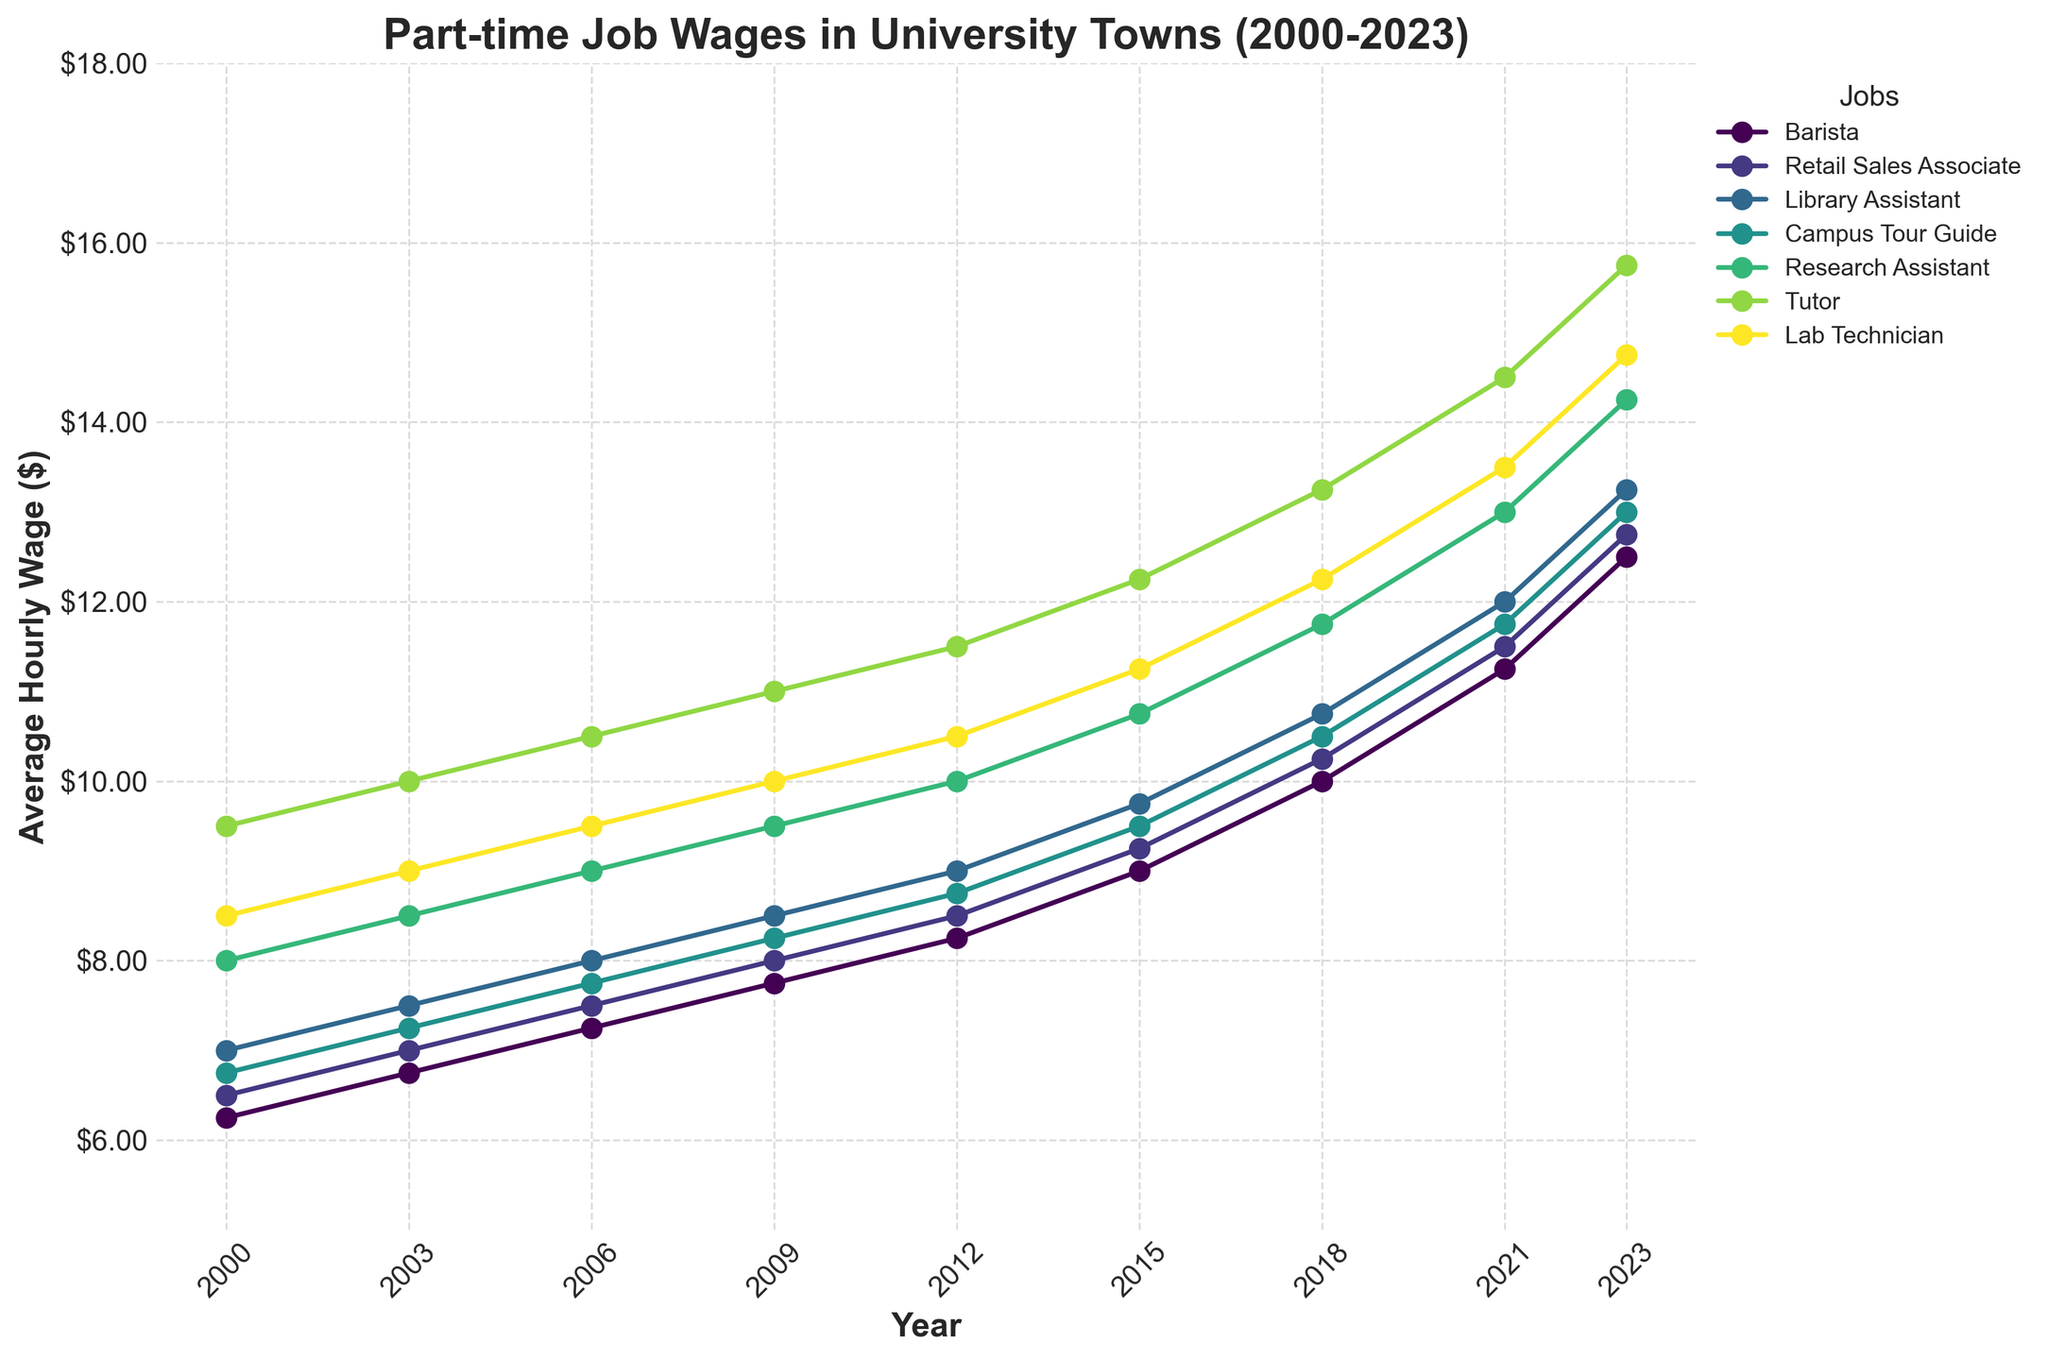What is the overall trend of the average hourly wage for Barista from 2000 to 2023? Look at the line representing the Barista wages from 2000 to 2023. The line increases steadily throughout the entire period, indicating that the average hourly wage for Baristas has been steadily rising from 6.25 in 2000 to 12.50 in 2023.
Answer: Steady increase Which job had the highest average hourly wage in 2023? Check the endpoints of the lines for 2023 and identify the line that reaches the highest point. The line representing Tutors reaches the highest at approximately $15.75 per hour.
Answer: Tutor Between 2000 and 2023, which job category had the smallest increase in average hourly wage? Calculate the difference in wages between 2023 and 2000 for each job. Barista: 12.50 - 6.25 = 6.25, Retail Sales Associate: 12.75 - 6.50 = 6.25, Library Assistant: 13.25 - 7.00 = 6.25, Campus Tour Guide: 13.00 - 6.75 = 6.25, Research Assistant: 14.25 - 8.00 = 6.25, Tutor: 15.75 - 9.50 = 6.25, Lab Technician: 14.75 - 8.50 = 6.25. All categories show an equal increase of $6.25.
Answer: All categories equally Which year saw the first time all job categories had an average hourly wage above $10? Visually inspect the lines and identify the first year where all are above the $10 mark. By 2018, all lines are seen to be above $10.
Answer: 2018 By how many dollars did the average wage for Campus Tour Guide increase from 2003 to 2023? Look at the wage values for Campus Tour Guide in 2003 (7.25) and 2023 (13.00). Subtract the 2003 value from the 2023 value: 13.00 - 7.25 = 5.75.
Answer: 5.75 Which job had the steepest increase in hourly wage between 2018 and 2021? Observe the slope of all lines between these two years. The Tutor wage line shows the steepest increase from approximately 13.25 to 14.50.
Answer: Tutor In 2023, how much higher is the average hourly wage for Lab Technician compared to Retail Sales Associate? Look at the 2023 values for Lab Technician (14.75) and Retail Sales Associate (12.75). Subtract the Retail Sales Associate wage from the Lab Technician wage: 14.75 - 12.75 = 2.00.
Answer: 2.00 What is the average hourly wage for a Library Assistant over the entire period (2000-2023)? Take the wages for Library Assistant across all years and calculate the average: (7.00 + 7.50 + 8.00 + 8.50 + 9.00 + 9.75 + 10.75 + 12.0 + 13.25) / 9 ≈ 9.25.
Answer: ≈9.25 Between which two consecutive years did the average hourly wage for Research Assistant show the greatest increase? Calculate the differences between consecutive years: 2003: 8.50-8.00 = 0.50, 2006: 9.00-8.50 = 0.50, 2009: 9.50-9.00 = 0.50, 2012: 10.00-9.50 = 0.50, 2015: 10.75-10.00 = 0.75, 2018: 11.75-10.75 = 1.00, 2021: 13.00-11.75 = 1.25, 2023: 14.25-13.00 = 1.25. The greatest increase of $1.25 occurs between 2018 and 2021, and between 2021 and 2023.
Answer: 2018-2021 and 2021-2023 Of all the job categories, which one showed the most consistent increase without any dips between 2000 and 2023? Examine each line and check for consistent upward trends without any decreases. All lines show a consistent upward trend without any dips.
Answer: All categories 